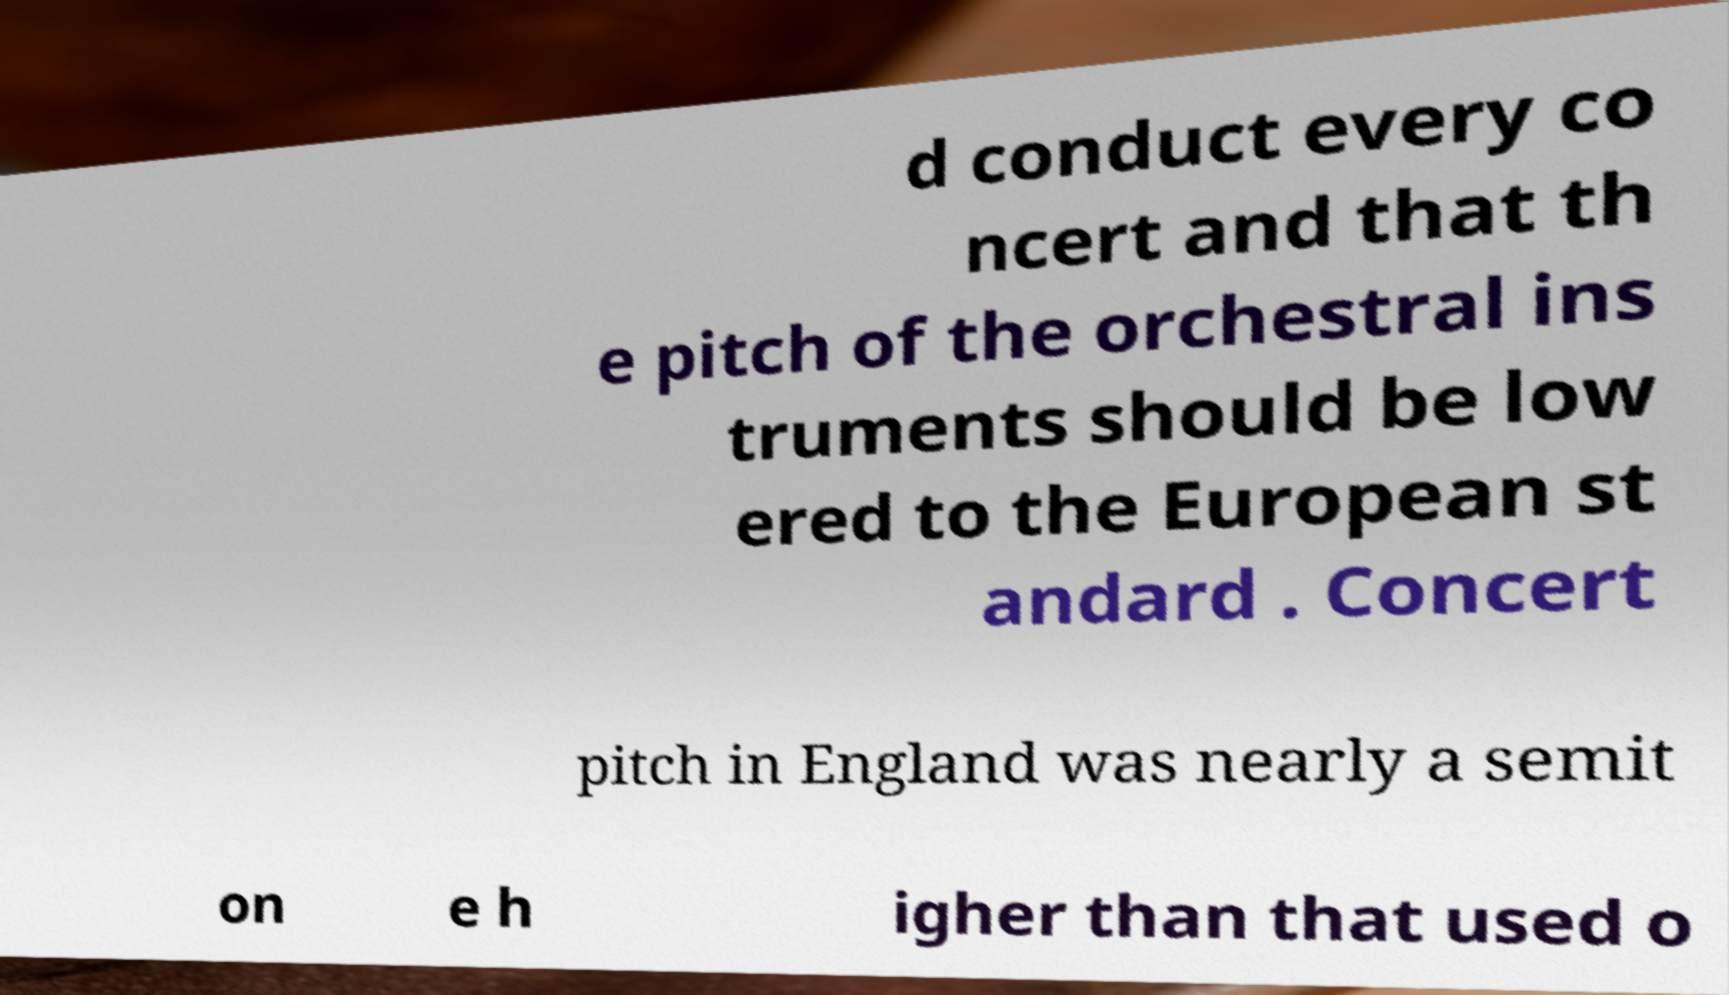Could you assist in decoding the text presented in this image and type it out clearly? d conduct every co ncert and that th e pitch of the orchestral ins truments should be low ered to the European st andard . Concert pitch in England was nearly a semit on e h igher than that used o 